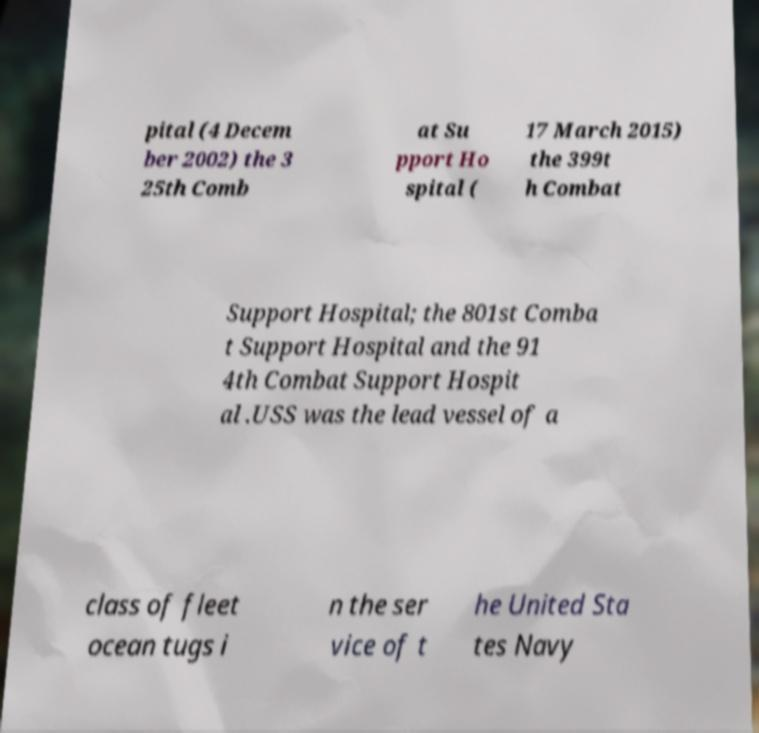Could you assist in decoding the text presented in this image and type it out clearly? pital (4 Decem ber 2002) the 3 25th Comb at Su pport Ho spital ( 17 March 2015) the 399t h Combat Support Hospital; the 801st Comba t Support Hospital and the 91 4th Combat Support Hospit al .USS was the lead vessel of a class of fleet ocean tugs i n the ser vice of t he United Sta tes Navy 